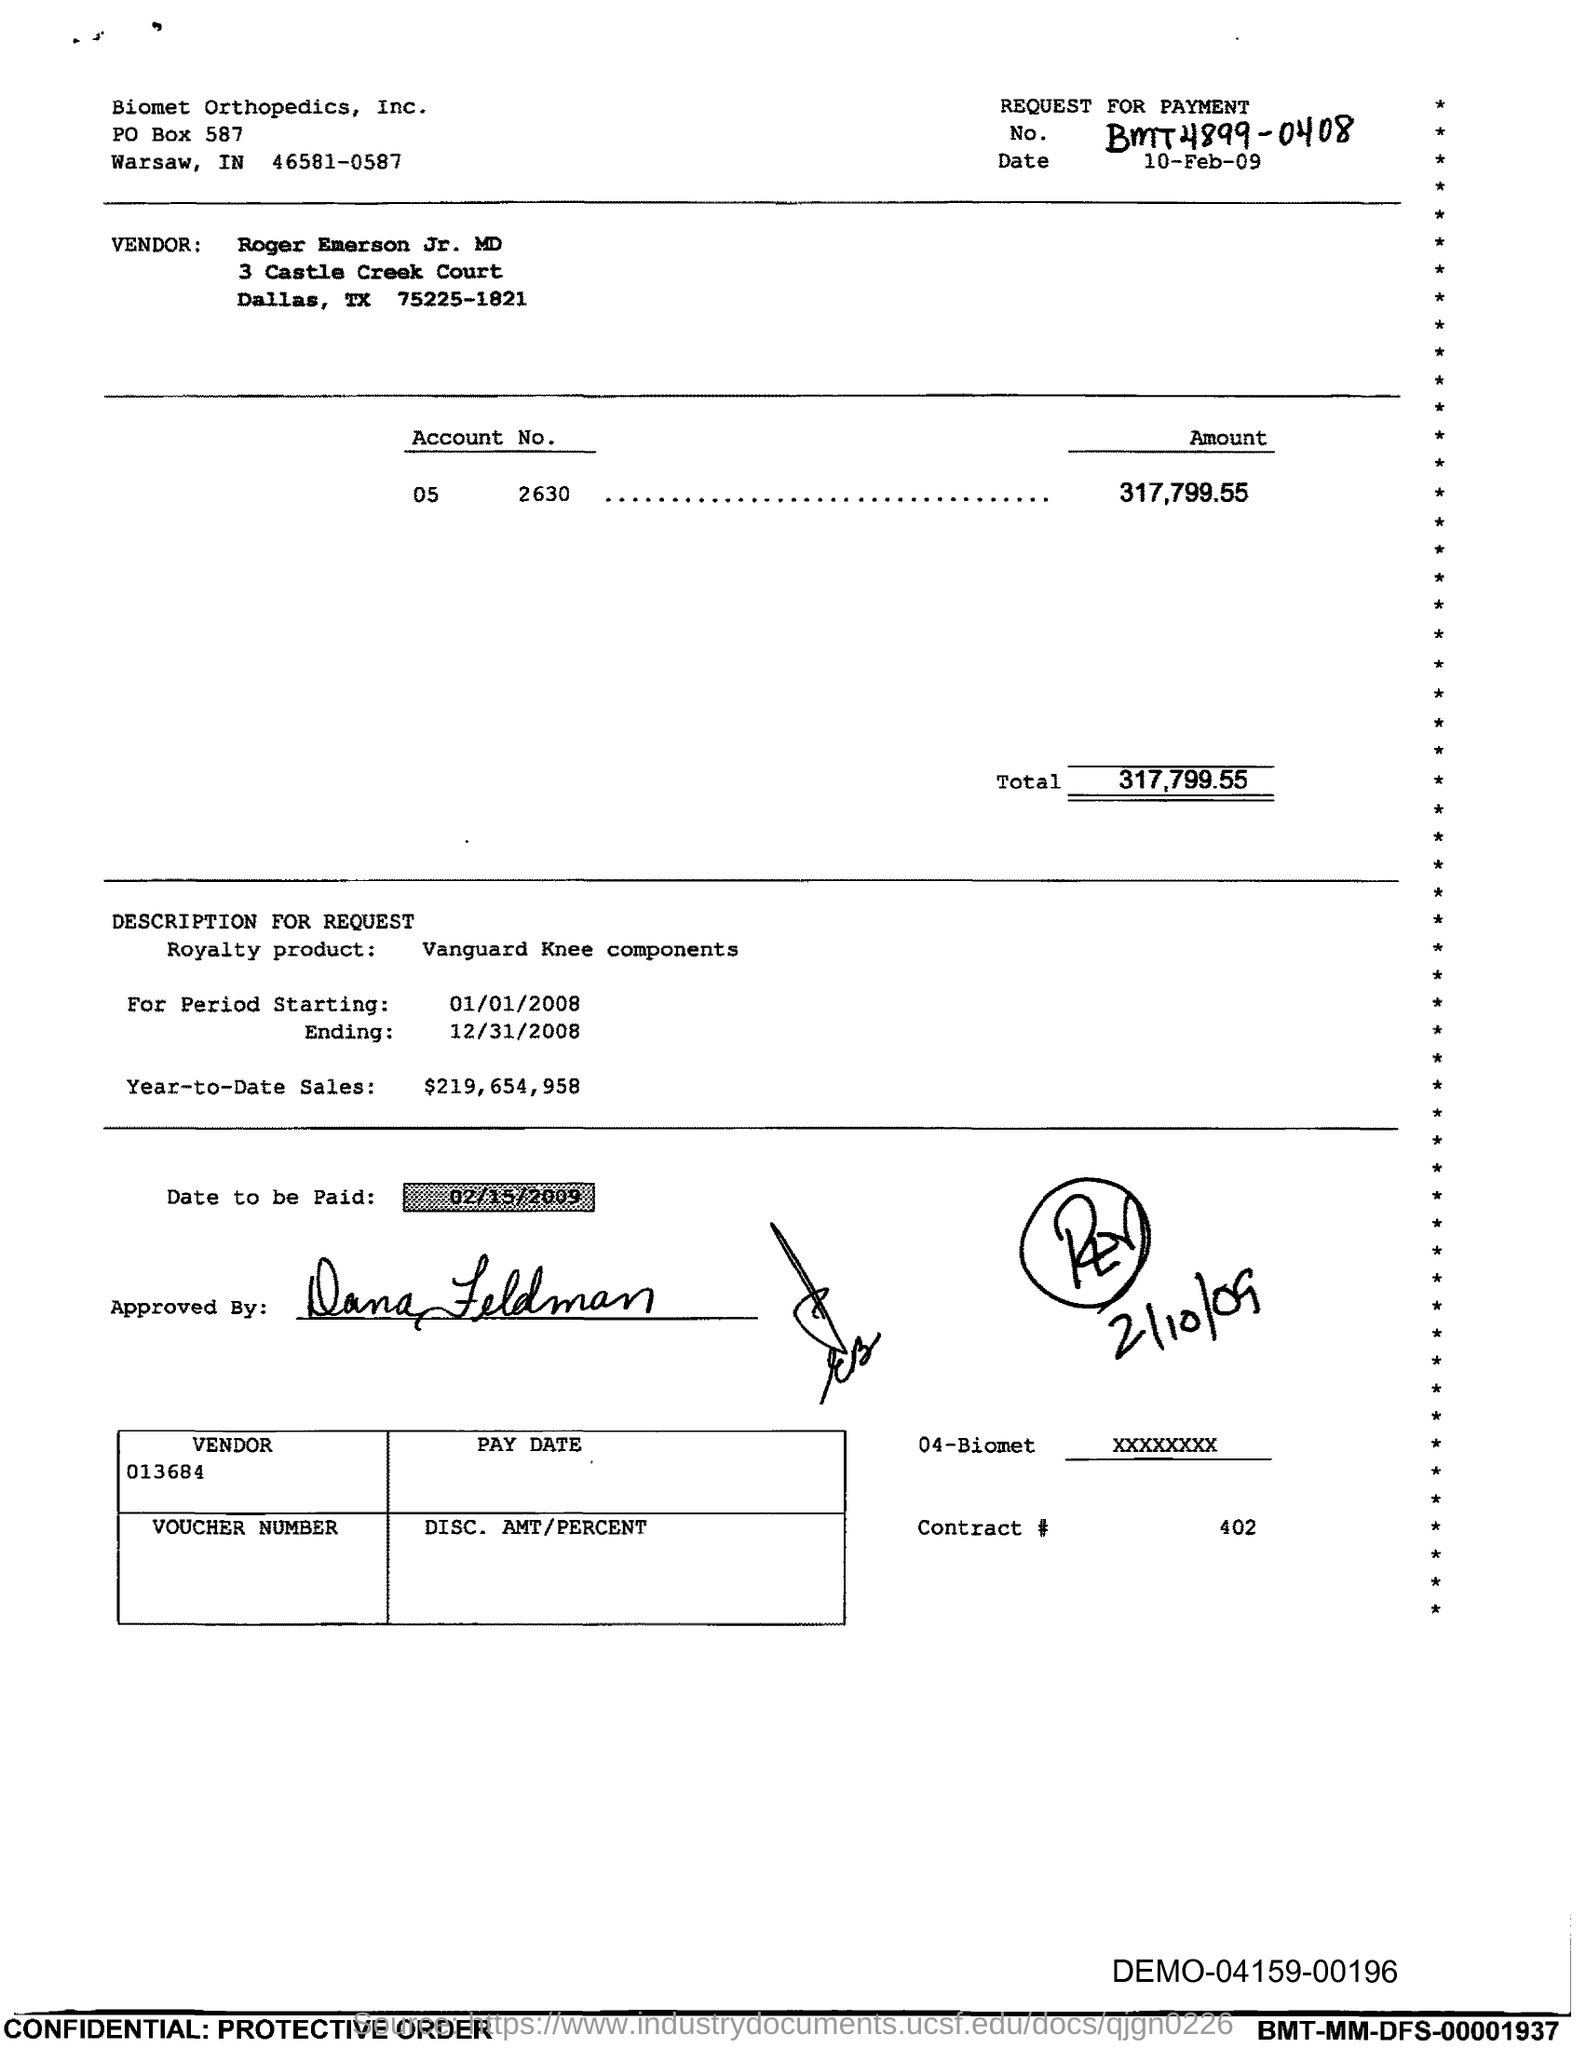Outline some significant characteristics in this image. The date to be paid mentioned in this document is February 15th, 2009. The amount mentioned in the document is 317,799.55. 